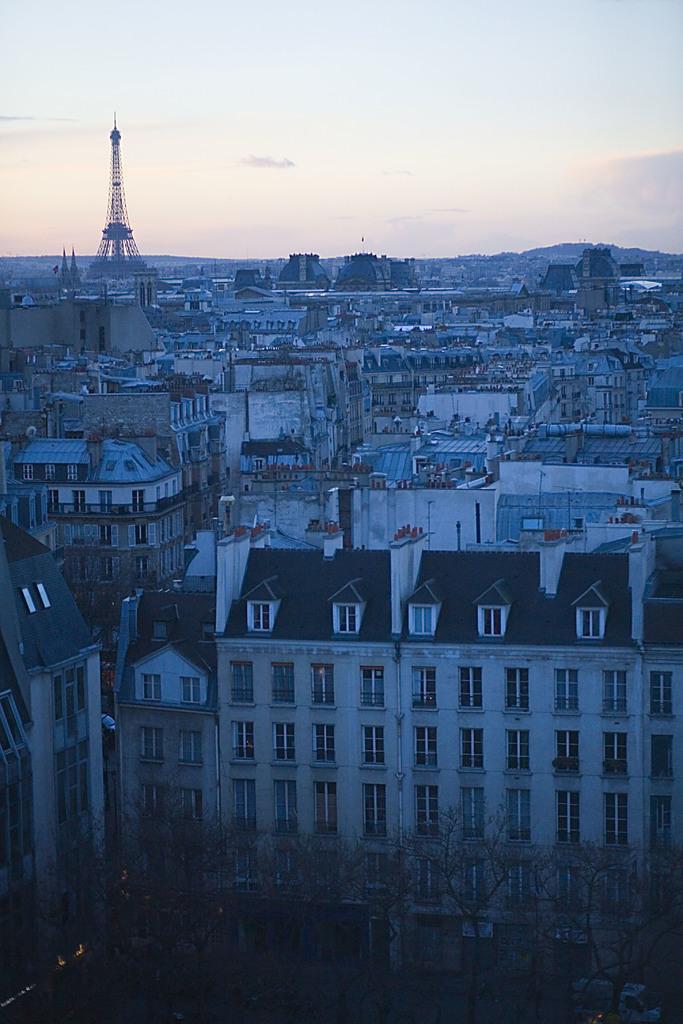In one or two sentences, can you explain what this image depicts? In this picture we can see trees, buildings, vehicle and tower. In the background of the image we can see the sky. 